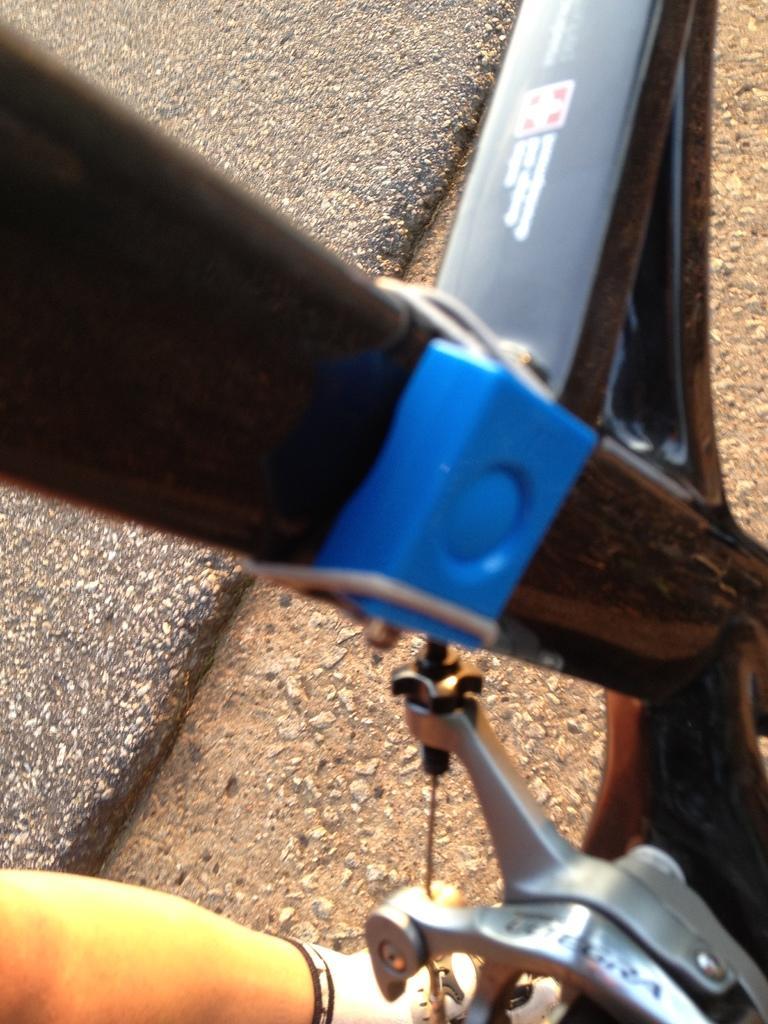In one or two sentences, can you explain what this image depicts? In this picture, we see the parts of the bicycle, which are in black, blue and grey color. At the bottom, we see the leg of the person who is wearing the white shoes. In the background, we see the road. 